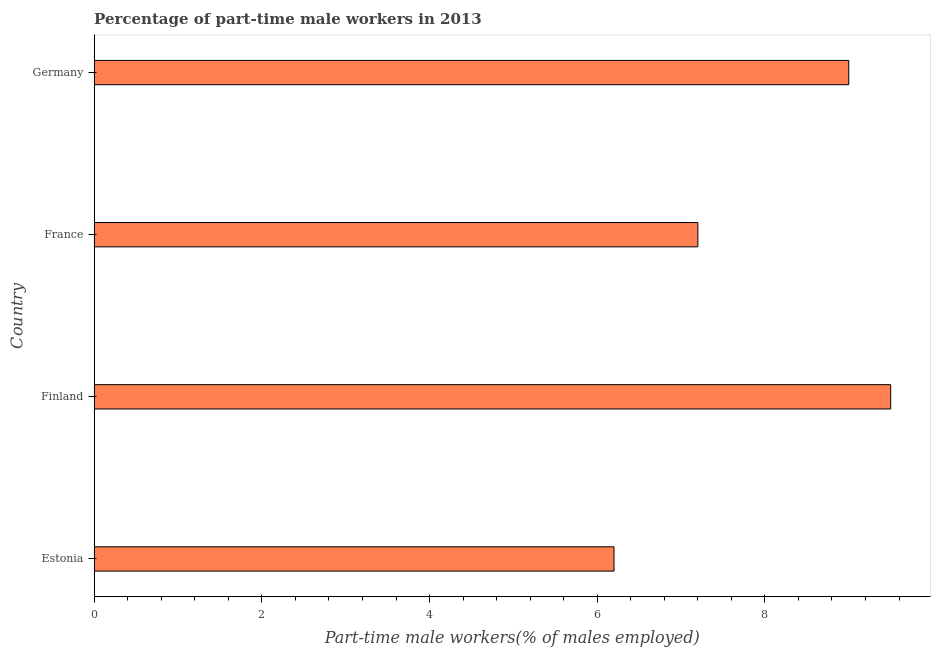Does the graph contain any zero values?
Offer a very short reply. No. Does the graph contain grids?
Your response must be concise. No. What is the title of the graph?
Make the answer very short. Percentage of part-time male workers in 2013. What is the label or title of the X-axis?
Provide a short and direct response. Part-time male workers(% of males employed). Across all countries, what is the maximum percentage of part-time male workers?
Make the answer very short. 9.5. Across all countries, what is the minimum percentage of part-time male workers?
Your answer should be compact. 6.2. In which country was the percentage of part-time male workers minimum?
Provide a succinct answer. Estonia. What is the sum of the percentage of part-time male workers?
Your answer should be very brief. 31.9. What is the average percentage of part-time male workers per country?
Make the answer very short. 7.97. What is the median percentage of part-time male workers?
Ensure brevity in your answer.  8.1. What is the ratio of the percentage of part-time male workers in Finland to that in Germany?
Provide a succinct answer. 1.06. Is the percentage of part-time male workers in Finland less than that in Germany?
Provide a short and direct response. No. Is the sum of the percentage of part-time male workers in France and Germany greater than the maximum percentage of part-time male workers across all countries?
Offer a terse response. Yes. What is the difference between the highest and the lowest percentage of part-time male workers?
Your answer should be compact. 3.3. How many bars are there?
Make the answer very short. 4. What is the difference between two consecutive major ticks on the X-axis?
Offer a terse response. 2. Are the values on the major ticks of X-axis written in scientific E-notation?
Keep it short and to the point. No. What is the Part-time male workers(% of males employed) of Estonia?
Provide a short and direct response. 6.2. What is the Part-time male workers(% of males employed) of France?
Offer a very short reply. 7.2. What is the difference between the Part-time male workers(% of males employed) in Estonia and Finland?
Provide a succinct answer. -3.3. What is the difference between the Part-time male workers(% of males employed) in Estonia and France?
Make the answer very short. -1. What is the difference between the Part-time male workers(% of males employed) in Estonia and Germany?
Give a very brief answer. -2.8. What is the difference between the Part-time male workers(% of males employed) in Finland and France?
Ensure brevity in your answer.  2.3. What is the difference between the Part-time male workers(% of males employed) in France and Germany?
Offer a very short reply. -1.8. What is the ratio of the Part-time male workers(% of males employed) in Estonia to that in Finland?
Provide a succinct answer. 0.65. What is the ratio of the Part-time male workers(% of males employed) in Estonia to that in France?
Offer a terse response. 0.86. What is the ratio of the Part-time male workers(% of males employed) in Estonia to that in Germany?
Offer a terse response. 0.69. What is the ratio of the Part-time male workers(% of males employed) in Finland to that in France?
Your response must be concise. 1.32. What is the ratio of the Part-time male workers(% of males employed) in Finland to that in Germany?
Provide a short and direct response. 1.06. What is the ratio of the Part-time male workers(% of males employed) in France to that in Germany?
Your response must be concise. 0.8. 